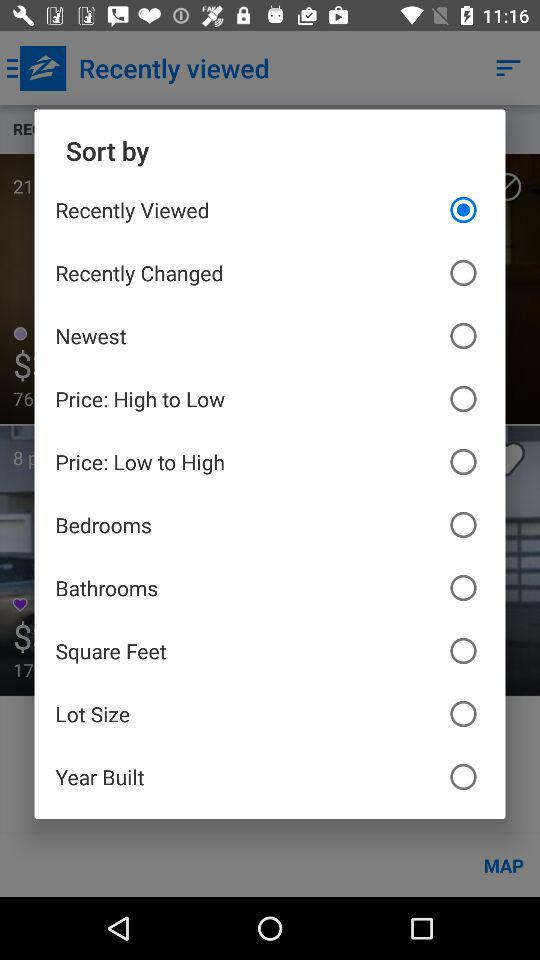Which option is selected? The selected option is "Recently Viewed". 